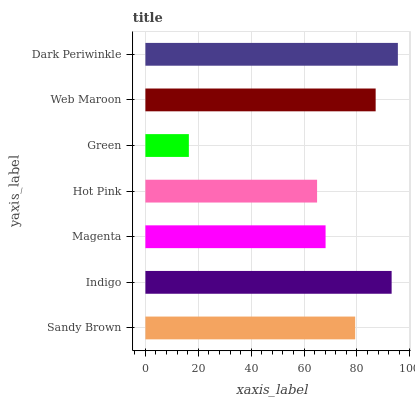Is Green the minimum?
Answer yes or no. Yes. Is Dark Periwinkle the maximum?
Answer yes or no. Yes. Is Indigo the minimum?
Answer yes or no. No. Is Indigo the maximum?
Answer yes or no. No. Is Indigo greater than Sandy Brown?
Answer yes or no. Yes. Is Sandy Brown less than Indigo?
Answer yes or no. Yes. Is Sandy Brown greater than Indigo?
Answer yes or no. No. Is Indigo less than Sandy Brown?
Answer yes or no. No. Is Sandy Brown the high median?
Answer yes or no. Yes. Is Sandy Brown the low median?
Answer yes or no. Yes. Is Hot Pink the high median?
Answer yes or no. No. Is Magenta the low median?
Answer yes or no. No. 